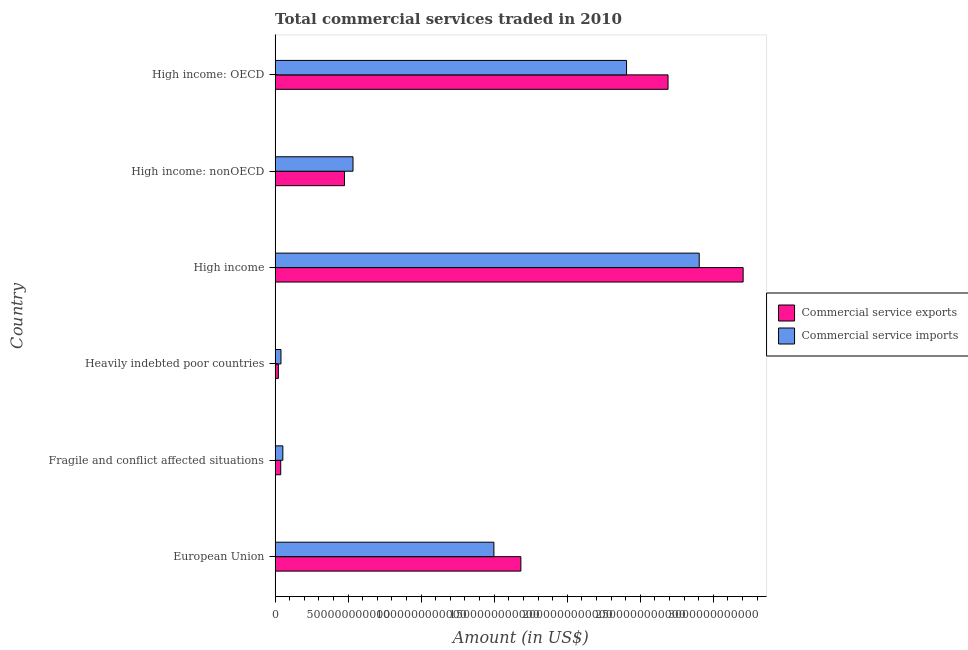How many groups of bars are there?
Give a very brief answer. 6. Are the number of bars per tick equal to the number of legend labels?
Keep it short and to the point. Yes. Are the number of bars on each tick of the Y-axis equal?
Your answer should be very brief. Yes. How many bars are there on the 1st tick from the top?
Your answer should be very brief. 2. How many bars are there on the 1st tick from the bottom?
Offer a very short reply. 2. What is the label of the 1st group of bars from the top?
Offer a very short reply. High income: OECD. In how many cases, is the number of bars for a given country not equal to the number of legend labels?
Your answer should be compact. 0. What is the amount of commercial service imports in High income: OECD?
Your answer should be very brief. 2.41e+12. Across all countries, what is the maximum amount of commercial service imports?
Keep it short and to the point. 2.90e+12. Across all countries, what is the minimum amount of commercial service imports?
Your response must be concise. 4.03e+1. In which country was the amount of commercial service exports minimum?
Your response must be concise. Heavily indebted poor countries. What is the total amount of commercial service imports in the graph?
Provide a succinct answer. 7.43e+12. What is the difference between the amount of commercial service exports in Fragile and conflict affected situations and that in Heavily indebted poor countries?
Provide a succinct answer. 1.61e+1. What is the difference between the amount of commercial service imports in High income and the amount of commercial service exports in High income: nonOECD?
Your answer should be very brief. 2.43e+12. What is the average amount of commercial service imports per country?
Provide a succinct answer. 1.24e+12. What is the difference between the amount of commercial service exports and amount of commercial service imports in High income: nonOECD?
Offer a terse response. -5.84e+1. What is the ratio of the amount of commercial service exports in European Union to that in High income: OECD?
Keep it short and to the point. 0.62. What is the difference between the highest and the second highest amount of commercial service exports?
Ensure brevity in your answer.  5.14e+11. What is the difference between the highest and the lowest amount of commercial service exports?
Make the answer very short. 3.18e+12. In how many countries, is the amount of commercial service imports greater than the average amount of commercial service imports taken over all countries?
Keep it short and to the point. 3. What does the 2nd bar from the top in Fragile and conflict affected situations represents?
Offer a terse response. Commercial service exports. What does the 1st bar from the bottom in Heavily indebted poor countries represents?
Make the answer very short. Commercial service exports. Are all the bars in the graph horizontal?
Offer a very short reply. Yes. How many countries are there in the graph?
Your answer should be compact. 6. What is the difference between two consecutive major ticks on the X-axis?
Give a very brief answer. 5.00e+11. What is the title of the graph?
Provide a short and direct response. Total commercial services traded in 2010. What is the label or title of the X-axis?
Provide a short and direct response. Amount (in US$). What is the Amount (in US$) of Commercial service exports in European Union?
Keep it short and to the point. 1.68e+12. What is the Amount (in US$) in Commercial service imports in European Union?
Offer a very short reply. 1.50e+12. What is the Amount (in US$) of Commercial service exports in Fragile and conflict affected situations?
Offer a very short reply. 3.86e+1. What is the Amount (in US$) in Commercial service imports in Fragile and conflict affected situations?
Make the answer very short. 5.32e+1. What is the Amount (in US$) in Commercial service exports in Heavily indebted poor countries?
Make the answer very short. 2.25e+1. What is the Amount (in US$) of Commercial service imports in Heavily indebted poor countries?
Provide a succinct answer. 4.03e+1. What is the Amount (in US$) of Commercial service exports in High income?
Provide a short and direct response. 3.20e+12. What is the Amount (in US$) in Commercial service imports in High income?
Make the answer very short. 2.90e+12. What is the Amount (in US$) of Commercial service exports in High income: nonOECD?
Provide a succinct answer. 4.75e+11. What is the Amount (in US$) of Commercial service imports in High income: nonOECD?
Make the answer very short. 5.33e+11. What is the Amount (in US$) in Commercial service exports in High income: OECD?
Ensure brevity in your answer.  2.69e+12. What is the Amount (in US$) in Commercial service imports in High income: OECD?
Provide a short and direct response. 2.41e+12. Across all countries, what is the maximum Amount (in US$) in Commercial service exports?
Ensure brevity in your answer.  3.20e+12. Across all countries, what is the maximum Amount (in US$) in Commercial service imports?
Ensure brevity in your answer.  2.90e+12. Across all countries, what is the minimum Amount (in US$) of Commercial service exports?
Your answer should be compact. 2.25e+1. Across all countries, what is the minimum Amount (in US$) in Commercial service imports?
Provide a short and direct response. 4.03e+1. What is the total Amount (in US$) of Commercial service exports in the graph?
Ensure brevity in your answer.  8.11e+12. What is the total Amount (in US$) in Commercial service imports in the graph?
Your answer should be compact. 7.43e+12. What is the difference between the Amount (in US$) in Commercial service exports in European Union and that in Fragile and conflict affected situations?
Ensure brevity in your answer.  1.64e+12. What is the difference between the Amount (in US$) of Commercial service imports in European Union and that in Fragile and conflict affected situations?
Ensure brevity in your answer.  1.44e+12. What is the difference between the Amount (in US$) in Commercial service exports in European Union and that in Heavily indebted poor countries?
Offer a terse response. 1.66e+12. What is the difference between the Amount (in US$) in Commercial service imports in European Union and that in Heavily indebted poor countries?
Your answer should be very brief. 1.46e+12. What is the difference between the Amount (in US$) in Commercial service exports in European Union and that in High income?
Make the answer very short. -1.52e+12. What is the difference between the Amount (in US$) of Commercial service imports in European Union and that in High income?
Provide a succinct answer. -1.41e+12. What is the difference between the Amount (in US$) of Commercial service exports in European Union and that in High income: nonOECD?
Offer a very short reply. 1.21e+12. What is the difference between the Amount (in US$) of Commercial service imports in European Union and that in High income: nonOECD?
Give a very brief answer. 9.65e+11. What is the difference between the Amount (in US$) in Commercial service exports in European Union and that in High income: OECD?
Your answer should be compact. -1.01e+12. What is the difference between the Amount (in US$) in Commercial service imports in European Union and that in High income: OECD?
Give a very brief answer. -9.08e+11. What is the difference between the Amount (in US$) in Commercial service exports in Fragile and conflict affected situations and that in Heavily indebted poor countries?
Offer a very short reply. 1.61e+1. What is the difference between the Amount (in US$) of Commercial service imports in Fragile and conflict affected situations and that in Heavily indebted poor countries?
Ensure brevity in your answer.  1.29e+1. What is the difference between the Amount (in US$) in Commercial service exports in Fragile and conflict affected situations and that in High income?
Keep it short and to the point. -3.17e+12. What is the difference between the Amount (in US$) of Commercial service imports in Fragile and conflict affected situations and that in High income?
Keep it short and to the point. -2.85e+12. What is the difference between the Amount (in US$) in Commercial service exports in Fragile and conflict affected situations and that in High income: nonOECD?
Keep it short and to the point. -4.36e+11. What is the difference between the Amount (in US$) in Commercial service imports in Fragile and conflict affected situations and that in High income: nonOECD?
Ensure brevity in your answer.  -4.80e+11. What is the difference between the Amount (in US$) of Commercial service exports in Fragile and conflict affected situations and that in High income: OECD?
Offer a very short reply. -2.65e+12. What is the difference between the Amount (in US$) in Commercial service imports in Fragile and conflict affected situations and that in High income: OECD?
Make the answer very short. -2.35e+12. What is the difference between the Amount (in US$) in Commercial service exports in Heavily indebted poor countries and that in High income?
Provide a short and direct response. -3.18e+12. What is the difference between the Amount (in US$) in Commercial service imports in Heavily indebted poor countries and that in High income?
Give a very brief answer. -2.86e+12. What is the difference between the Amount (in US$) in Commercial service exports in Heavily indebted poor countries and that in High income: nonOECD?
Offer a very short reply. -4.53e+11. What is the difference between the Amount (in US$) in Commercial service imports in Heavily indebted poor countries and that in High income: nonOECD?
Keep it short and to the point. -4.93e+11. What is the difference between the Amount (in US$) in Commercial service exports in Heavily indebted poor countries and that in High income: OECD?
Make the answer very short. -2.67e+12. What is the difference between the Amount (in US$) in Commercial service imports in Heavily indebted poor countries and that in High income: OECD?
Offer a very short reply. -2.37e+12. What is the difference between the Amount (in US$) in Commercial service exports in High income and that in High income: nonOECD?
Ensure brevity in your answer.  2.73e+12. What is the difference between the Amount (in US$) in Commercial service imports in High income and that in High income: nonOECD?
Give a very brief answer. 2.37e+12. What is the difference between the Amount (in US$) of Commercial service exports in High income and that in High income: OECD?
Give a very brief answer. 5.14e+11. What is the difference between the Amount (in US$) of Commercial service imports in High income and that in High income: OECD?
Your answer should be compact. 4.98e+11. What is the difference between the Amount (in US$) of Commercial service exports in High income: nonOECD and that in High income: OECD?
Your answer should be very brief. -2.22e+12. What is the difference between the Amount (in US$) in Commercial service imports in High income: nonOECD and that in High income: OECD?
Keep it short and to the point. -1.87e+12. What is the difference between the Amount (in US$) in Commercial service exports in European Union and the Amount (in US$) in Commercial service imports in Fragile and conflict affected situations?
Offer a terse response. 1.63e+12. What is the difference between the Amount (in US$) of Commercial service exports in European Union and the Amount (in US$) of Commercial service imports in Heavily indebted poor countries?
Your answer should be very brief. 1.64e+12. What is the difference between the Amount (in US$) in Commercial service exports in European Union and the Amount (in US$) in Commercial service imports in High income?
Make the answer very short. -1.22e+12. What is the difference between the Amount (in US$) of Commercial service exports in European Union and the Amount (in US$) of Commercial service imports in High income: nonOECD?
Offer a very short reply. 1.15e+12. What is the difference between the Amount (in US$) in Commercial service exports in European Union and the Amount (in US$) in Commercial service imports in High income: OECD?
Your answer should be compact. -7.23e+11. What is the difference between the Amount (in US$) of Commercial service exports in Fragile and conflict affected situations and the Amount (in US$) of Commercial service imports in Heavily indebted poor countries?
Make the answer very short. -1.71e+09. What is the difference between the Amount (in US$) of Commercial service exports in Fragile and conflict affected situations and the Amount (in US$) of Commercial service imports in High income?
Ensure brevity in your answer.  -2.87e+12. What is the difference between the Amount (in US$) of Commercial service exports in Fragile and conflict affected situations and the Amount (in US$) of Commercial service imports in High income: nonOECD?
Ensure brevity in your answer.  -4.95e+11. What is the difference between the Amount (in US$) of Commercial service exports in Fragile and conflict affected situations and the Amount (in US$) of Commercial service imports in High income: OECD?
Your response must be concise. -2.37e+12. What is the difference between the Amount (in US$) in Commercial service exports in Heavily indebted poor countries and the Amount (in US$) in Commercial service imports in High income?
Your response must be concise. -2.88e+12. What is the difference between the Amount (in US$) of Commercial service exports in Heavily indebted poor countries and the Amount (in US$) of Commercial service imports in High income: nonOECD?
Offer a very short reply. -5.11e+11. What is the difference between the Amount (in US$) in Commercial service exports in Heavily indebted poor countries and the Amount (in US$) in Commercial service imports in High income: OECD?
Keep it short and to the point. -2.38e+12. What is the difference between the Amount (in US$) in Commercial service exports in High income and the Amount (in US$) in Commercial service imports in High income: nonOECD?
Give a very brief answer. 2.67e+12. What is the difference between the Amount (in US$) of Commercial service exports in High income and the Amount (in US$) of Commercial service imports in High income: OECD?
Provide a short and direct response. 7.98e+11. What is the difference between the Amount (in US$) of Commercial service exports in High income: nonOECD and the Amount (in US$) of Commercial service imports in High income: OECD?
Your answer should be very brief. -1.93e+12. What is the average Amount (in US$) of Commercial service exports per country?
Offer a terse response. 1.35e+12. What is the average Amount (in US$) of Commercial service imports per country?
Offer a terse response. 1.24e+12. What is the difference between the Amount (in US$) in Commercial service exports and Amount (in US$) in Commercial service imports in European Union?
Ensure brevity in your answer.  1.85e+11. What is the difference between the Amount (in US$) in Commercial service exports and Amount (in US$) in Commercial service imports in Fragile and conflict affected situations?
Your answer should be very brief. -1.46e+1. What is the difference between the Amount (in US$) of Commercial service exports and Amount (in US$) of Commercial service imports in Heavily indebted poor countries?
Provide a succinct answer. -1.78e+1. What is the difference between the Amount (in US$) in Commercial service exports and Amount (in US$) in Commercial service imports in High income?
Keep it short and to the point. 3.01e+11. What is the difference between the Amount (in US$) in Commercial service exports and Amount (in US$) in Commercial service imports in High income: nonOECD?
Your response must be concise. -5.84e+1. What is the difference between the Amount (in US$) of Commercial service exports and Amount (in US$) of Commercial service imports in High income: OECD?
Your response must be concise. 2.84e+11. What is the ratio of the Amount (in US$) in Commercial service exports in European Union to that in Fragile and conflict affected situations?
Your answer should be very brief. 43.61. What is the ratio of the Amount (in US$) of Commercial service imports in European Union to that in Fragile and conflict affected situations?
Provide a short and direct response. 28.16. What is the ratio of the Amount (in US$) of Commercial service exports in European Union to that in Heavily indebted poor countries?
Your response must be concise. 74.83. What is the ratio of the Amount (in US$) of Commercial service imports in European Union to that in Heavily indebted poor countries?
Make the answer very short. 37.18. What is the ratio of the Amount (in US$) in Commercial service exports in European Union to that in High income?
Your response must be concise. 0.53. What is the ratio of the Amount (in US$) of Commercial service imports in European Union to that in High income?
Offer a very short reply. 0.52. What is the ratio of the Amount (in US$) of Commercial service exports in European Union to that in High income: nonOECD?
Your answer should be very brief. 3.54. What is the ratio of the Amount (in US$) of Commercial service imports in European Union to that in High income: nonOECD?
Your response must be concise. 2.81. What is the ratio of the Amount (in US$) in Commercial service exports in European Union to that in High income: OECD?
Your response must be concise. 0.63. What is the ratio of the Amount (in US$) in Commercial service imports in European Union to that in High income: OECD?
Ensure brevity in your answer.  0.62. What is the ratio of the Amount (in US$) in Commercial service exports in Fragile and conflict affected situations to that in Heavily indebted poor countries?
Make the answer very short. 1.72. What is the ratio of the Amount (in US$) in Commercial service imports in Fragile and conflict affected situations to that in Heavily indebted poor countries?
Provide a succinct answer. 1.32. What is the ratio of the Amount (in US$) of Commercial service exports in Fragile and conflict affected situations to that in High income?
Keep it short and to the point. 0.01. What is the ratio of the Amount (in US$) in Commercial service imports in Fragile and conflict affected situations to that in High income?
Provide a succinct answer. 0.02. What is the ratio of the Amount (in US$) in Commercial service exports in Fragile and conflict affected situations to that in High income: nonOECD?
Keep it short and to the point. 0.08. What is the ratio of the Amount (in US$) of Commercial service imports in Fragile and conflict affected situations to that in High income: nonOECD?
Provide a succinct answer. 0.1. What is the ratio of the Amount (in US$) in Commercial service exports in Fragile and conflict affected situations to that in High income: OECD?
Provide a succinct answer. 0.01. What is the ratio of the Amount (in US$) in Commercial service imports in Fragile and conflict affected situations to that in High income: OECD?
Your response must be concise. 0.02. What is the ratio of the Amount (in US$) of Commercial service exports in Heavily indebted poor countries to that in High income?
Give a very brief answer. 0.01. What is the ratio of the Amount (in US$) of Commercial service imports in Heavily indebted poor countries to that in High income?
Provide a short and direct response. 0.01. What is the ratio of the Amount (in US$) of Commercial service exports in Heavily indebted poor countries to that in High income: nonOECD?
Make the answer very short. 0.05. What is the ratio of the Amount (in US$) in Commercial service imports in Heavily indebted poor countries to that in High income: nonOECD?
Your response must be concise. 0.08. What is the ratio of the Amount (in US$) of Commercial service exports in Heavily indebted poor countries to that in High income: OECD?
Provide a short and direct response. 0.01. What is the ratio of the Amount (in US$) in Commercial service imports in Heavily indebted poor countries to that in High income: OECD?
Your answer should be compact. 0.02. What is the ratio of the Amount (in US$) in Commercial service exports in High income to that in High income: nonOECD?
Your response must be concise. 6.75. What is the ratio of the Amount (in US$) in Commercial service imports in High income to that in High income: nonOECD?
Provide a short and direct response. 5.44. What is the ratio of the Amount (in US$) of Commercial service exports in High income to that in High income: OECD?
Make the answer very short. 1.19. What is the ratio of the Amount (in US$) of Commercial service imports in High income to that in High income: OECD?
Ensure brevity in your answer.  1.21. What is the ratio of the Amount (in US$) in Commercial service exports in High income: nonOECD to that in High income: OECD?
Your answer should be very brief. 0.18. What is the ratio of the Amount (in US$) of Commercial service imports in High income: nonOECD to that in High income: OECD?
Offer a very short reply. 0.22. What is the difference between the highest and the second highest Amount (in US$) of Commercial service exports?
Your answer should be compact. 5.14e+11. What is the difference between the highest and the second highest Amount (in US$) in Commercial service imports?
Your response must be concise. 4.98e+11. What is the difference between the highest and the lowest Amount (in US$) in Commercial service exports?
Offer a terse response. 3.18e+12. What is the difference between the highest and the lowest Amount (in US$) of Commercial service imports?
Your answer should be compact. 2.86e+12. 